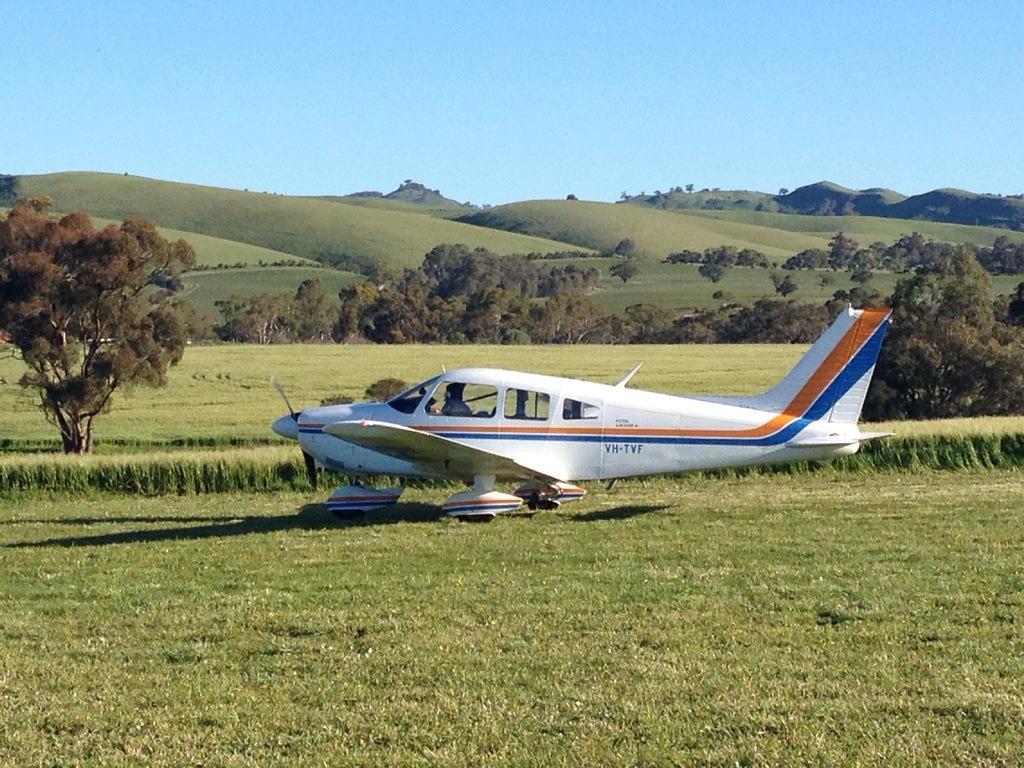Please provide a concise description of this image. In this picture we can see an airplane on the grass, trees, mountains and in the background we can see the sky. 